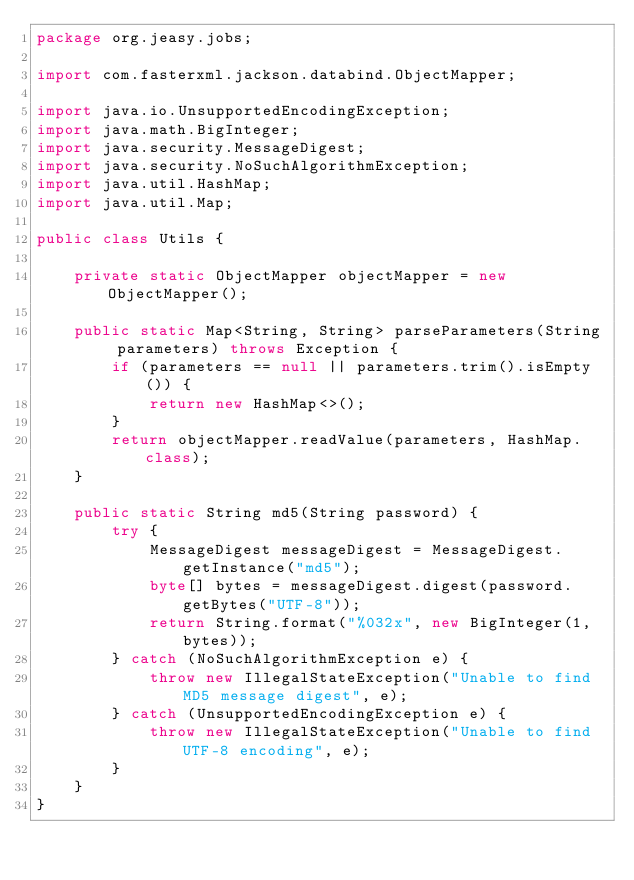<code> <loc_0><loc_0><loc_500><loc_500><_Java_>package org.jeasy.jobs;

import com.fasterxml.jackson.databind.ObjectMapper;

import java.io.UnsupportedEncodingException;
import java.math.BigInteger;
import java.security.MessageDigest;
import java.security.NoSuchAlgorithmException;
import java.util.HashMap;
import java.util.Map;

public class Utils {

    private static ObjectMapper objectMapper = new ObjectMapper();

    public static Map<String, String> parseParameters(String parameters) throws Exception {
        if (parameters == null || parameters.trim().isEmpty()) {
            return new HashMap<>();
        }
        return objectMapper.readValue(parameters, HashMap.class);
    }

    public static String md5(String password) {
        try {
            MessageDigest messageDigest = MessageDigest.getInstance("md5");
            byte[] bytes = messageDigest.digest(password.getBytes("UTF-8"));
            return String.format("%032x", new BigInteger(1, bytes));
        } catch (NoSuchAlgorithmException e) {
            throw new IllegalStateException("Unable to find MD5 message digest", e);
        } catch (UnsupportedEncodingException e) {
            throw new IllegalStateException("Unable to find UTF-8 encoding", e);
        }
    }
}
</code> 